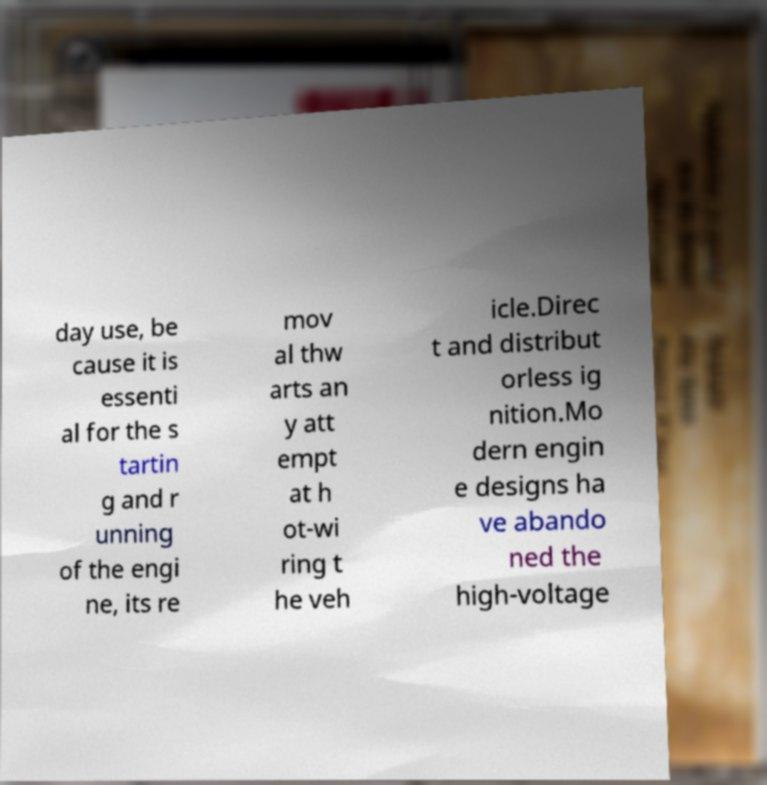Can you accurately transcribe the text from the provided image for me? day use, be cause it is essenti al for the s tartin g and r unning of the engi ne, its re mov al thw arts an y att empt at h ot-wi ring t he veh icle.Direc t and distribut orless ig nition.Mo dern engin e designs ha ve abando ned the high-voltage 